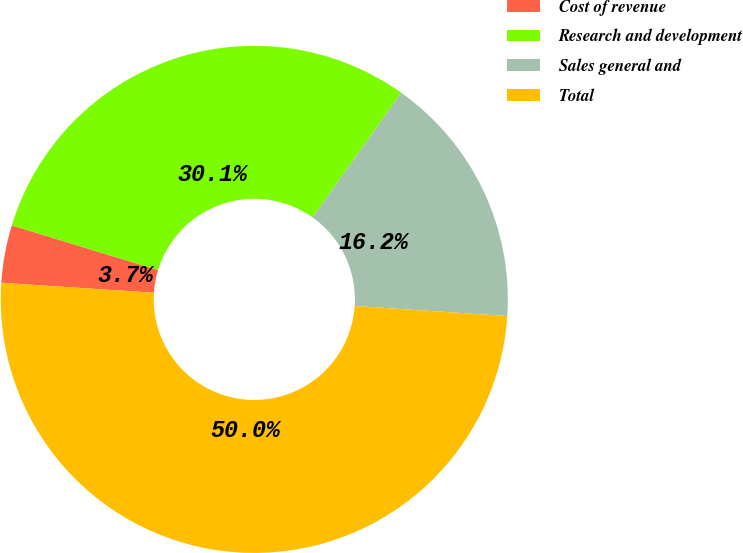<chart> <loc_0><loc_0><loc_500><loc_500><pie_chart><fcel>Cost of revenue<fcel>Research and development<fcel>Sales general and<fcel>Total<nl><fcel>3.67%<fcel>30.12%<fcel>16.21%<fcel>50.0%<nl></chart> 